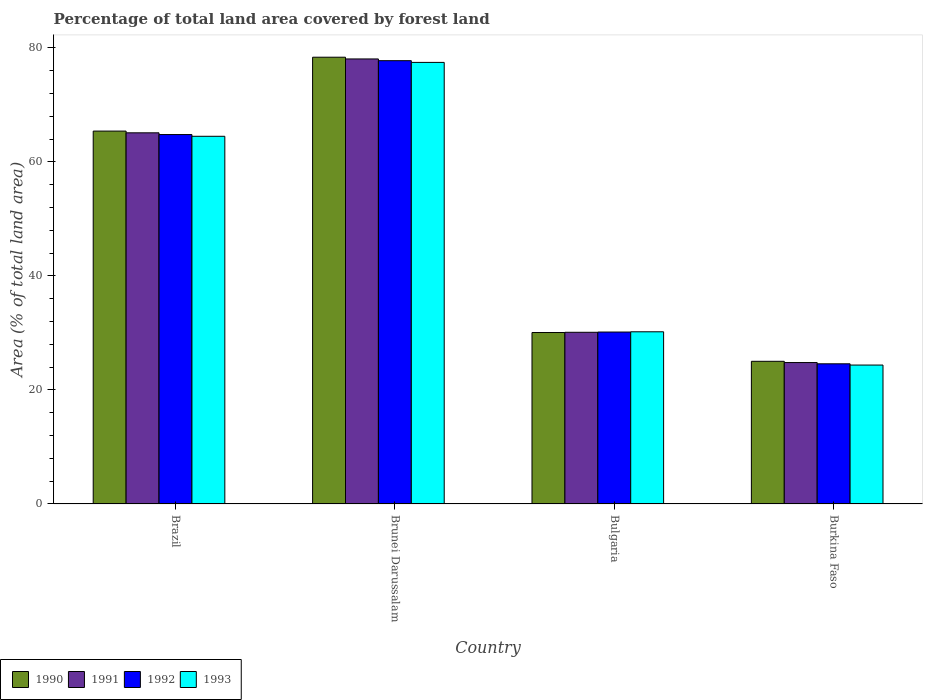How many different coloured bars are there?
Provide a short and direct response. 4. Are the number of bars on each tick of the X-axis equal?
Your response must be concise. Yes. What is the label of the 1st group of bars from the left?
Your answer should be compact. Brazil. What is the percentage of forest land in 1990 in Burkina Faso?
Your answer should be compact. 25.03. Across all countries, what is the maximum percentage of forest land in 1990?
Your answer should be compact. 78.37. Across all countries, what is the minimum percentage of forest land in 1990?
Ensure brevity in your answer.  25.03. In which country was the percentage of forest land in 1993 maximum?
Offer a very short reply. Brunei Darussalam. In which country was the percentage of forest land in 1993 minimum?
Keep it short and to the point. Burkina Faso. What is the total percentage of forest land in 1990 in the graph?
Provide a short and direct response. 198.88. What is the difference between the percentage of forest land in 1991 in Brunei Darussalam and that in Burkina Faso?
Give a very brief answer. 53.26. What is the difference between the percentage of forest land in 1991 in Brazil and the percentage of forest land in 1990 in Burkina Faso?
Your response must be concise. 40.08. What is the average percentage of forest land in 1992 per country?
Keep it short and to the point. 49.33. What is the difference between the percentage of forest land of/in 1993 and percentage of forest land of/in 1992 in Brazil?
Your response must be concise. -0.3. What is the ratio of the percentage of forest land in 1993 in Brunei Darussalam to that in Burkina Faso?
Provide a short and direct response. 3.18. What is the difference between the highest and the second highest percentage of forest land in 1990?
Provide a succinct answer. -12.96. What is the difference between the highest and the lowest percentage of forest land in 1993?
Offer a very short reply. 53.09. Is it the case that in every country, the sum of the percentage of forest land in 1993 and percentage of forest land in 1992 is greater than the sum of percentage of forest land in 1990 and percentage of forest land in 1991?
Offer a terse response. No. What does the 2nd bar from the left in Burkina Faso represents?
Provide a succinct answer. 1991. What does the 3rd bar from the right in Bulgaria represents?
Your response must be concise. 1991. How many bars are there?
Offer a very short reply. 16. How many countries are there in the graph?
Make the answer very short. 4. What is the difference between two consecutive major ticks on the Y-axis?
Offer a very short reply. 20. Are the values on the major ticks of Y-axis written in scientific E-notation?
Your answer should be compact. No. Does the graph contain grids?
Ensure brevity in your answer.  No. Where does the legend appear in the graph?
Provide a short and direct response. Bottom left. How many legend labels are there?
Offer a very short reply. 4. What is the title of the graph?
Provide a short and direct response. Percentage of total land area covered by forest land. What is the label or title of the Y-axis?
Keep it short and to the point. Area (% of total land area). What is the Area (% of total land area) of 1990 in Brazil?
Offer a very short reply. 65.41. What is the Area (% of total land area) in 1991 in Brazil?
Your answer should be very brief. 65.11. What is the Area (% of total land area) in 1992 in Brazil?
Offer a very short reply. 64.8. What is the Area (% of total land area) of 1993 in Brazil?
Your answer should be compact. 64.5. What is the Area (% of total land area) of 1990 in Brunei Darussalam?
Your answer should be very brief. 78.37. What is the Area (% of total land area) in 1991 in Brunei Darussalam?
Provide a succinct answer. 78.06. What is the Area (% of total land area) in 1992 in Brunei Darussalam?
Give a very brief answer. 77.76. What is the Area (% of total land area) in 1993 in Brunei Darussalam?
Your answer should be compact. 77.46. What is the Area (% of total land area) in 1990 in Bulgaria?
Make the answer very short. 30.07. What is the Area (% of total land area) of 1991 in Bulgaria?
Give a very brief answer. 30.12. What is the Area (% of total land area) in 1992 in Bulgaria?
Make the answer very short. 30.16. What is the Area (% of total land area) in 1993 in Bulgaria?
Your answer should be compact. 30.2. What is the Area (% of total land area) of 1990 in Burkina Faso?
Your answer should be compact. 25.03. What is the Area (% of total land area) in 1991 in Burkina Faso?
Make the answer very short. 24.81. What is the Area (% of total land area) in 1992 in Burkina Faso?
Your answer should be very brief. 24.59. What is the Area (% of total land area) in 1993 in Burkina Faso?
Your answer should be compact. 24.37. Across all countries, what is the maximum Area (% of total land area) in 1990?
Provide a short and direct response. 78.37. Across all countries, what is the maximum Area (% of total land area) of 1991?
Your response must be concise. 78.06. Across all countries, what is the maximum Area (% of total land area) in 1992?
Keep it short and to the point. 77.76. Across all countries, what is the maximum Area (% of total land area) of 1993?
Provide a succinct answer. 77.46. Across all countries, what is the minimum Area (% of total land area) in 1990?
Your answer should be compact. 25.03. Across all countries, what is the minimum Area (% of total land area) in 1991?
Make the answer very short. 24.81. Across all countries, what is the minimum Area (% of total land area) of 1992?
Keep it short and to the point. 24.59. Across all countries, what is the minimum Area (% of total land area) in 1993?
Ensure brevity in your answer.  24.37. What is the total Area (% of total land area) in 1990 in the graph?
Make the answer very short. 198.88. What is the total Area (% of total land area) of 1991 in the graph?
Your response must be concise. 198.09. What is the total Area (% of total land area) of 1992 in the graph?
Ensure brevity in your answer.  197.31. What is the total Area (% of total land area) in 1993 in the graph?
Your answer should be very brief. 196.53. What is the difference between the Area (% of total land area) in 1990 in Brazil and that in Brunei Darussalam?
Provide a succinct answer. -12.96. What is the difference between the Area (% of total land area) in 1991 in Brazil and that in Brunei Darussalam?
Keep it short and to the point. -12.96. What is the difference between the Area (% of total land area) in 1992 in Brazil and that in Brunei Darussalam?
Your response must be concise. -12.96. What is the difference between the Area (% of total land area) in 1993 in Brazil and that in Brunei Darussalam?
Provide a short and direct response. -12.96. What is the difference between the Area (% of total land area) in 1990 in Brazil and that in Bulgaria?
Give a very brief answer. 35.34. What is the difference between the Area (% of total land area) in 1991 in Brazil and that in Bulgaria?
Your answer should be compact. 34.99. What is the difference between the Area (% of total land area) of 1992 in Brazil and that in Bulgaria?
Give a very brief answer. 34.64. What is the difference between the Area (% of total land area) of 1993 in Brazil and that in Bulgaria?
Your answer should be very brief. 34.29. What is the difference between the Area (% of total land area) of 1990 in Brazil and that in Burkina Faso?
Your answer should be compact. 40.38. What is the difference between the Area (% of total land area) in 1991 in Brazil and that in Burkina Faso?
Give a very brief answer. 40.3. What is the difference between the Area (% of total land area) in 1992 in Brazil and that in Burkina Faso?
Your answer should be compact. 40.21. What is the difference between the Area (% of total land area) of 1993 in Brazil and that in Burkina Faso?
Your answer should be very brief. 40.13. What is the difference between the Area (% of total land area) of 1990 in Brunei Darussalam and that in Bulgaria?
Keep it short and to the point. 48.29. What is the difference between the Area (% of total land area) in 1991 in Brunei Darussalam and that in Bulgaria?
Offer a very short reply. 47.95. What is the difference between the Area (% of total land area) in 1992 in Brunei Darussalam and that in Bulgaria?
Your answer should be very brief. 47.6. What is the difference between the Area (% of total land area) of 1993 in Brunei Darussalam and that in Bulgaria?
Keep it short and to the point. 47.25. What is the difference between the Area (% of total land area) of 1990 in Brunei Darussalam and that in Burkina Faso?
Offer a terse response. 53.34. What is the difference between the Area (% of total land area) in 1991 in Brunei Darussalam and that in Burkina Faso?
Offer a very short reply. 53.26. What is the difference between the Area (% of total land area) of 1992 in Brunei Darussalam and that in Burkina Faso?
Keep it short and to the point. 53.17. What is the difference between the Area (% of total land area) in 1993 in Brunei Darussalam and that in Burkina Faso?
Keep it short and to the point. 53.09. What is the difference between the Area (% of total land area) in 1990 in Bulgaria and that in Burkina Faso?
Your answer should be compact. 5.05. What is the difference between the Area (% of total land area) of 1991 in Bulgaria and that in Burkina Faso?
Ensure brevity in your answer.  5.31. What is the difference between the Area (% of total land area) of 1992 in Bulgaria and that in Burkina Faso?
Your answer should be compact. 5.57. What is the difference between the Area (% of total land area) of 1993 in Bulgaria and that in Burkina Faso?
Provide a succinct answer. 5.83. What is the difference between the Area (% of total land area) in 1990 in Brazil and the Area (% of total land area) in 1991 in Brunei Darussalam?
Make the answer very short. -12.65. What is the difference between the Area (% of total land area) in 1990 in Brazil and the Area (% of total land area) in 1992 in Brunei Darussalam?
Your answer should be compact. -12.35. What is the difference between the Area (% of total land area) in 1990 in Brazil and the Area (% of total land area) in 1993 in Brunei Darussalam?
Provide a short and direct response. -12.05. What is the difference between the Area (% of total land area) in 1991 in Brazil and the Area (% of total land area) in 1992 in Brunei Darussalam?
Offer a very short reply. -12.66. What is the difference between the Area (% of total land area) of 1991 in Brazil and the Area (% of total land area) of 1993 in Brunei Darussalam?
Ensure brevity in your answer.  -12.35. What is the difference between the Area (% of total land area) in 1992 in Brazil and the Area (% of total land area) in 1993 in Brunei Darussalam?
Offer a terse response. -12.66. What is the difference between the Area (% of total land area) of 1990 in Brazil and the Area (% of total land area) of 1991 in Bulgaria?
Your response must be concise. 35.29. What is the difference between the Area (% of total land area) in 1990 in Brazil and the Area (% of total land area) in 1992 in Bulgaria?
Ensure brevity in your answer.  35.25. What is the difference between the Area (% of total land area) in 1990 in Brazil and the Area (% of total land area) in 1993 in Bulgaria?
Offer a very short reply. 35.21. What is the difference between the Area (% of total land area) of 1991 in Brazil and the Area (% of total land area) of 1992 in Bulgaria?
Provide a short and direct response. 34.95. What is the difference between the Area (% of total land area) in 1991 in Brazil and the Area (% of total land area) in 1993 in Bulgaria?
Ensure brevity in your answer.  34.9. What is the difference between the Area (% of total land area) in 1992 in Brazil and the Area (% of total land area) in 1993 in Bulgaria?
Your answer should be very brief. 34.6. What is the difference between the Area (% of total land area) in 1990 in Brazil and the Area (% of total land area) in 1991 in Burkina Faso?
Your answer should be very brief. 40.6. What is the difference between the Area (% of total land area) of 1990 in Brazil and the Area (% of total land area) of 1992 in Burkina Faso?
Give a very brief answer. 40.82. What is the difference between the Area (% of total land area) in 1990 in Brazil and the Area (% of total land area) in 1993 in Burkina Faso?
Your response must be concise. 41.04. What is the difference between the Area (% of total land area) in 1991 in Brazil and the Area (% of total land area) in 1992 in Burkina Faso?
Ensure brevity in your answer.  40.52. What is the difference between the Area (% of total land area) in 1991 in Brazil and the Area (% of total land area) in 1993 in Burkina Faso?
Offer a terse response. 40.74. What is the difference between the Area (% of total land area) of 1992 in Brazil and the Area (% of total land area) of 1993 in Burkina Faso?
Provide a succinct answer. 40.43. What is the difference between the Area (% of total land area) of 1990 in Brunei Darussalam and the Area (% of total land area) of 1991 in Bulgaria?
Give a very brief answer. 48.25. What is the difference between the Area (% of total land area) in 1990 in Brunei Darussalam and the Area (% of total land area) in 1992 in Bulgaria?
Your response must be concise. 48.21. What is the difference between the Area (% of total land area) of 1990 in Brunei Darussalam and the Area (% of total land area) of 1993 in Bulgaria?
Offer a terse response. 48.16. What is the difference between the Area (% of total land area) of 1991 in Brunei Darussalam and the Area (% of total land area) of 1992 in Bulgaria?
Offer a very short reply. 47.9. What is the difference between the Area (% of total land area) in 1991 in Brunei Darussalam and the Area (% of total land area) in 1993 in Bulgaria?
Offer a terse response. 47.86. What is the difference between the Area (% of total land area) in 1992 in Brunei Darussalam and the Area (% of total land area) in 1993 in Bulgaria?
Give a very brief answer. 47.56. What is the difference between the Area (% of total land area) in 1990 in Brunei Darussalam and the Area (% of total land area) in 1991 in Burkina Faso?
Provide a succinct answer. 53.56. What is the difference between the Area (% of total land area) of 1990 in Brunei Darussalam and the Area (% of total land area) of 1992 in Burkina Faso?
Your response must be concise. 53.78. What is the difference between the Area (% of total land area) of 1990 in Brunei Darussalam and the Area (% of total land area) of 1993 in Burkina Faso?
Your answer should be compact. 54. What is the difference between the Area (% of total land area) in 1991 in Brunei Darussalam and the Area (% of total land area) in 1992 in Burkina Faso?
Provide a short and direct response. 53.48. What is the difference between the Area (% of total land area) of 1991 in Brunei Darussalam and the Area (% of total land area) of 1993 in Burkina Faso?
Your response must be concise. 53.7. What is the difference between the Area (% of total land area) of 1992 in Brunei Darussalam and the Area (% of total land area) of 1993 in Burkina Faso?
Keep it short and to the point. 53.39. What is the difference between the Area (% of total land area) of 1990 in Bulgaria and the Area (% of total land area) of 1991 in Burkina Faso?
Offer a terse response. 5.27. What is the difference between the Area (% of total land area) in 1990 in Bulgaria and the Area (% of total land area) in 1992 in Burkina Faso?
Your answer should be very brief. 5.49. What is the difference between the Area (% of total land area) of 1990 in Bulgaria and the Area (% of total land area) of 1993 in Burkina Faso?
Your answer should be compact. 5.7. What is the difference between the Area (% of total land area) of 1991 in Bulgaria and the Area (% of total land area) of 1992 in Burkina Faso?
Offer a terse response. 5.53. What is the difference between the Area (% of total land area) of 1991 in Bulgaria and the Area (% of total land area) of 1993 in Burkina Faso?
Your answer should be very brief. 5.75. What is the difference between the Area (% of total land area) of 1992 in Bulgaria and the Area (% of total land area) of 1993 in Burkina Faso?
Offer a very short reply. 5.79. What is the average Area (% of total land area) in 1990 per country?
Offer a very short reply. 49.72. What is the average Area (% of total land area) in 1991 per country?
Offer a terse response. 49.52. What is the average Area (% of total land area) in 1992 per country?
Offer a very short reply. 49.33. What is the average Area (% of total land area) in 1993 per country?
Your response must be concise. 49.13. What is the difference between the Area (% of total land area) of 1990 and Area (% of total land area) of 1991 in Brazil?
Provide a short and direct response. 0.3. What is the difference between the Area (% of total land area) of 1990 and Area (% of total land area) of 1992 in Brazil?
Provide a succinct answer. 0.61. What is the difference between the Area (% of total land area) in 1990 and Area (% of total land area) in 1993 in Brazil?
Offer a terse response. 0.91. What is the difference between the Area (% of total land area) of 1991 and Area (% of total land area) of 1992 in Brazil?
Your answer should be compact. 0.3. What is the difference between the Area (% of total land area) of 1991 and Area (% of total land area) of 1993 in Brazil?
Make the answer very short. 0.61. What is the difference between the Area (% of total land area) of 1992 and Area (% of total land area) of 1993 in Brazil?
Give a very brief answer. 0.3. What is the difference between the Area (% of total land area) of 1990 and Area (% of total land area) of 1991 in Brunei Darussalam?
Offer a very short reply. 0.3. What is the difference between the Area (% of total land area) of 1990 and Area (% of total land area) of 1992 in Brunei Darussalam?
Keep it short and to the point. 0.61. What is the difference between the Area (% of total land area) in 1990 and Area (% of total land area) in 1993 in Brunei Darussalam?
Provide a succinct answer. 0.91. What is the difference between the Area (% of total land area) in 1991 and Area (% of total land area) in 1992 in Brunei Darussalam?
Make the answer very short. 0.3. What is the difference between the Area (% of total land area) in 1991 and Area (% of total land area) in 1993 in Brunei Darussalam?
Your response must be concise. 0.61. What is the difference between the Area (% of total land area) in 1992 and Area (% of total land area) in 1993 in Brunei Darussalam?
Your response must be concise. 0.3. What is the difference between the Area (% of total land area) of 1990 and Area (% of total land area) of 1991 in Bulgaria?
Your response must be concise. -0.04. What is the difference between the Area (% of total land area) of 1990 and Area (% of total land area) of 1992 in Bulgaria?
Your answer should be compact. -0.09. What is the difference between the Area (% of total land area) in 1990 and Area (% of total land area) in 1993 in Bulgaria?
Make the answer very short. -0.13. What is the difference between the Area (% of total land area) in 1991 and Area (% of total land area) in 1992 in Bulgaria?
Give a very brief answer. -0.04. What is the difference between the Area (% of total land area) of 1991 and Area (% of total land area) of 1993 in Bulgaria?
Offer a terse response. -0.09. What is the difference between the Area (% of total land area) of 1992 and Area (% of total land area) of 1993 in Bulgaria?
Offer a very short reply. -0.04. What is the difference between the Area (% of total land area) in 1990 and Area (% of total land area) in 1991 in Burkina Faso?
Offer a terse response. 0.22. What is the difference between the Area (% of total land area) in 1990 and Area (% of total land area) in 1992 in Burkina Faso?
Keep it short and to the point. 0.44. What is the difference between the Area (% of total land area) in 1990 and Area (% of total land area) in 1993 in Burkina Faso?
Provide a succinct answer. 0.66. What is the difference between the Area (% of total land area) in 1991 and Area (% of total land area) in 1992 in Burkina Faso?
Your response must be concise. 0.22. What is the difference between the Area (% of total land area) in 1991 and Area (% of total land area) in 1993 in Burkina Faso?
Your response must be concise. 0.44. What is the difference between the Area (% of total land area) in 1992 and Area (% of total land area) in 1993 in Burkina Faso?
Provide a succinct answer. 0.22. What is the ratio of the Area (% of total land area) of 1990 in Brazil to that in Brunei Darussalam?
Make the answer very short. 0.83. What is the ratio of the Area (% of total land area) of 1991 in Brazil to that in Brunei Darussalam?
Ensure brevity in your answer.  0.83. What is the ratio of the Area (% of total land area) in 1993 in Brazil to that in Brunei Darussalam?
Provide a succinct answer. 0.83. What is the ratio of the Area (% of total land area) of 1990 in Brazil to that in Bulgaria?
Offer a terse response. 2.17. What is the ratio of the Area (% of total land area) of 1991 in Brazil to that in Bulgaria?
Provide a short and direct response. 2.16. What is the ratio of the Area (% of total land area) of 1992 in Brazil to that in Bulgaria?
Your answer should be compact. 2.15. What is the ratio of the Area (% of total land area) in 1993 in Brazil to that in Bulgaria?
Offer a very short reply. 2.14. What is the ratio of the Area (% of total land area) in 1990 in Brazil to that in Burkina Faso?
Your answer should be compact. 2.61. What is the ratio of the Area (% of total land area) in 1991 in Brazil to that in Burkina Faso?
Give a very brief answer. 2.62. What is the ratio of the Area (% of total land area) of 1992 in Brazil to that in Burkina Faso?
Provide a short and direct response. 2.64. What is the ratio of the Area (% of total land area) of 1993 in Brazil to that in Burkina Faso?
Provide a short and direct response. 2.65. What is the ratio of the Area (% of total land area) in 1990 in Brunei Darussalam to that in Bulgaria?
Ensure brevity in your answer.  2.61. What is the ratio of the Area (% of total land area) in 1991 in Brunei Darussalam to that in Bulgaria?
Offer a very short reply. 2.59. What is the ratio of the Area (% of total land area) of 1992 in Brunei Darussalam to that in Bulgaria?
Give a very brief answer. 2.58. What is the ratio of the Area (% of total land area) in 1993 in Brunei Darussalam to that in Bulgaria?
Make the answer very short. 2.56. What is the ratio of the Area (% of total land area) of 1990 in Brunei Darussalam to that in Burkina Faso?
Your response must be concise. 3.13. What is the ratio of the Area (% of total land area) in 1991 in Brunei Darussalam to that in Burkina Faso?
Ensure brevity in your answer.  3.15. What is the ratio of the Area (% of total land area) of 1992 in Brunei Darussalam to that in Burkina Faso?
Give a very brief answer. 3.16. What is the ratio of the Area (% of total land area) in 1993 in Brunei Darussalam to that in Burkina Faso?
Keep it short and to the point. 3.18. What is the ratio of the Area (% of total land area) of 1990 in Bulgaria to that in Burkina Faso?
Your answer should be compact. 1.2. What is the ratio of the Area (% of total land area) in 1991 in Bulgaria to that in Burkina Faso?
Provide a short and direct response. 1.21. What is the ratio of the Area (% of total land area) in 1992 in Bulgaria to that in Burkina Faso?
Give a very brief answer. 1.23. What is the ratio of the Area (% of total land area) of 1993 in Bulgaria to that in Burkina Faso?
Make the answer very short. 1.24. What is the difference between the highest and the second highest Area (% of total land area) of 1990?
Ensure brevity in your answer.  12.96. What is the difference between the highest and the second highest Area (% of total land area) in 1991?
Offer a very short reply. 12.96. What is the difference between the highest and the second highest Area (% of total land area) of 1992?
Your answer should be very brief. 12.96. What is the difference between the highest and the second highest Area (% of total land area) in 1993?
Offer a very short reply. 12.96. What is the difference between the highest and the lowest Area (% of total land area) in 1990?
Your answer should be compact. 53.34. What is the difference between the highest and the lowest Area (% of total land area) of 1991?
Offer a very short reply. 53.26. What is the difference between the highest and the lowest Area (% of total land area) in 1992?
Give a very brief answer. 53.17. What is the difference between the highest and the lowest Area (% of total land area) of 1993?
Provide a succinct answer. 53.09. 